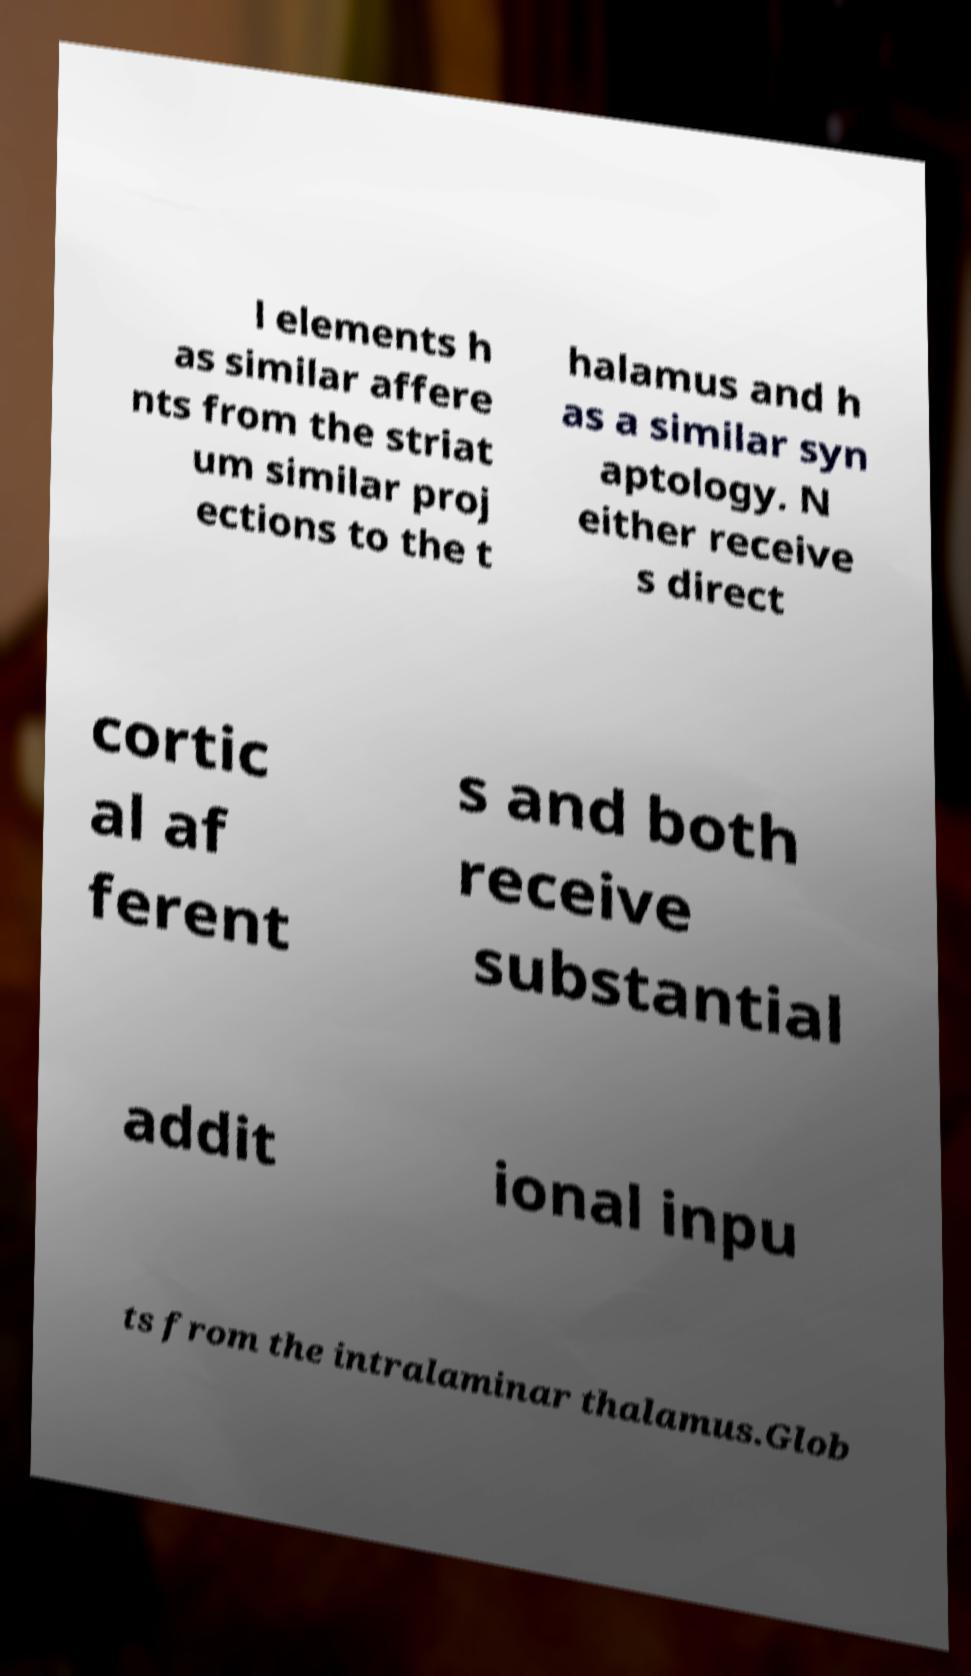What messages or text are displayed in this image? I need them in a readable, typed format. l elements h as similar affere nts from the striat um similar proj ections to the t halamus and h as a similar syn aptology. N either receive s direct cortic al af ferent s and both receive substantial addit ional inpu ts from the intralaminar thalamus.Glob 